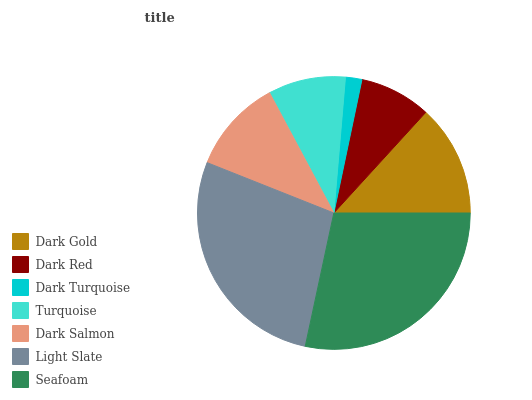Is Dark Turquoise the minimum?
Answer yes or no. Yes. Is Seafoam the maximum?
Answer yes or no. Yes. Is Dark Red the minimum?
Answer yes or no. No. Is Dark Red the maximum?
Answer yes or no. No. Is Dark Gold greater than Dark Red?
Answer yes or no. Yes. Is Dark Red less than Dark Gold?
Answer yes or no. Yes. Is Dark Red greater than Dark Gold?
Answer yes or no. No. Is Dark Gold less than Dark Red?
Answer yes or no. No. Is Dark Salmon the high median?
Answer yes or no. Yes. Is Dark Salmon the low median?
Answer yes or no. Yes. Is Dark Turquoise the high median?
Answer yes or no. No. Is Seafoam the low median?
Answer yes or no. No. 